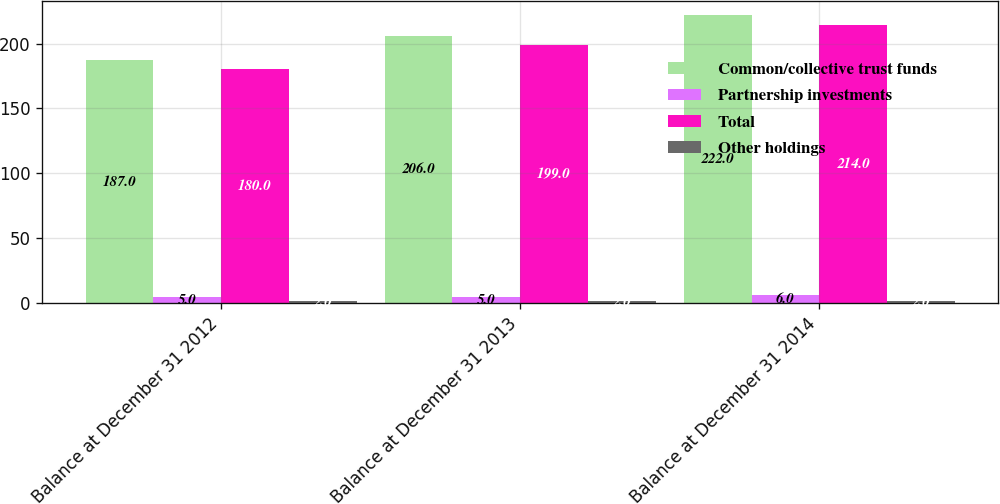<chart> <loc_0><loc_0><loc_500><loc_500><stacked_bar_chart><ecel><fcel>Balance at December 31 2012<fcel>Balance at December 31 2013<fcel>Balance at December 31 2014<nl><fcel>Common/collective trust funds<fcel>187<fcel>206<fcel>222<nl><fcel>Partnership investments<fcel>5<fcel>5<fcel>6<nl><fcel>Total<fcel>180<fcel>199<fcel>214<nl><fcel>Other holdings<fcel>2<fcel>2<fcel>2<nl></chart> 